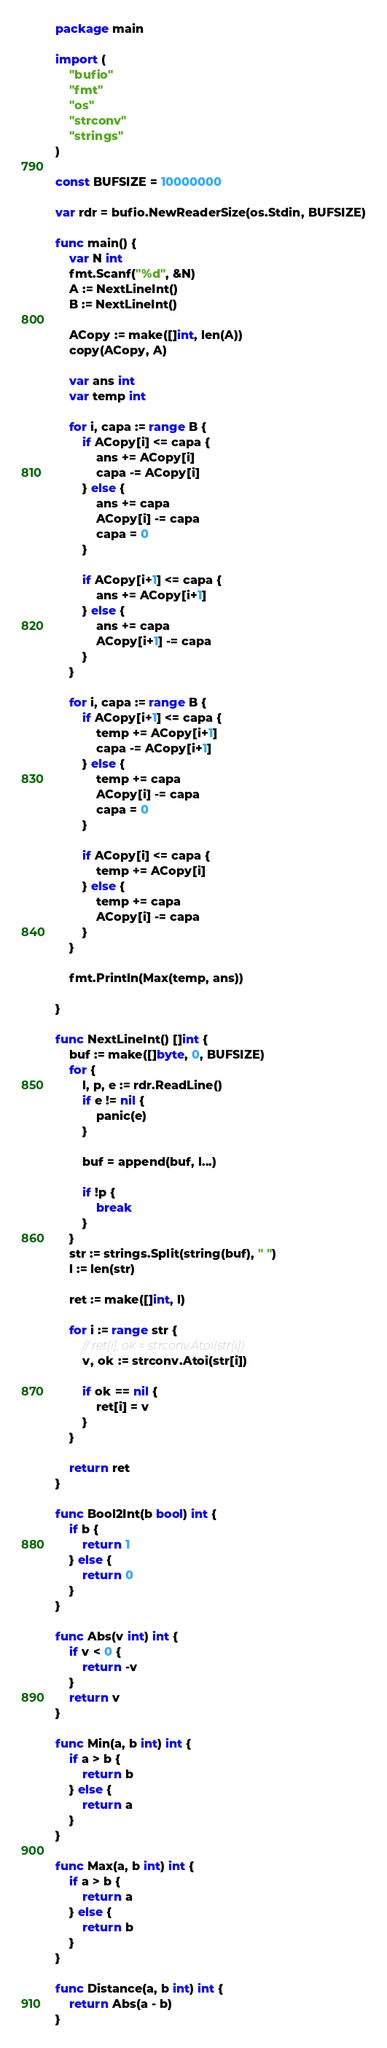<code> <loc_0><loc_0><loc_500><loc_500><_Go_>package main

import (
	"bufio"
	"fmt"
	"os"
	"strconv"
	"strings"
)

const BUFSIZE = 10000000

var rdr = bufio.NewReaderSize(os.Stdin, BUFSIZE)

func main() {
	var N int
	fmt.Scanf("%d", &N)
	A := NextLineInt()
	B := NextLineInt()

	ACopy := make([]int, len(A))
	copy(ACopy, A)

	var ans int
	var temp int

	for i, capa := range B {
		if ACopy[i] <= capa {
			ans += ACopy[i]
			capa -= ACopy[i]
		} else {
			ans += capa
			ACopy[i] -= capa
			capa = 0
		}

		if ACopy[i+1] <= capa {
			ans += ACopy[i+1]
		} else {
			ans += capa
			ACopy[i+1] -= capa
		}
	}

	for i, capa := range B {
		if ACopy[i+1] <= capa {
			temp += ACopy[i+1]
			capa -= ACopy[i+1]
		} else {
			temp += capa
			ACopy[i] -= capa
			capa = 0
		}

		if ACopy[i] <= capa {
			temp += ACopy[i]
		} else {
			temp += capa
			ACopy[i] -= capa
		}
	}

	fmt.Println(Max(temp, ans))

}

func NextLineInt() []int {
	buf := make([]byte, 0, BUFSIZE)
	for {
		l, p, e := rdr.ReadLine()
		if e != nil {
			panic(e)
		}

		buf = append(buf, l...)

		if !p {
			break
		}
	}
	str := strings.Split(string(buf), " ")
	l := len(str)

	ret := make([]int, l)

	for i := range str {
		// ret[i], ok = strconv.Atoi(str[i])
		v, ok := strconv.Atoi(str[i])

		if ok == nil {
			ret[i] = v
		}
	}

	return ret
}

func Bool2Int(b bool) int {
	if b {
		return 1
	} else {
		return 0
	}
}

func Abs(v int) int {
	if v < 0 {
		return -v
	}
	return v
}

func Min(a, b int) int {
	if a > b {
		return b
	} else {
		return a
	}
}

func Max(a, b int) int {
	if a > b {
		return a
	} else {
		return b
	}
}

func Distance(a, b int) int {
	return Abs(a - b)
}
</code> 